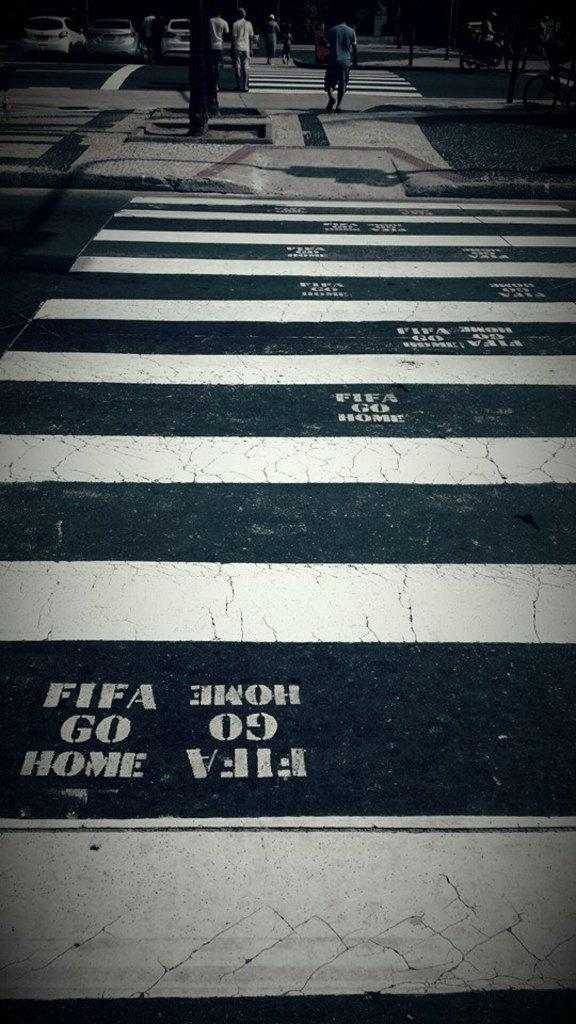What are the people in the image doing? The people in the image are walking. Where are the people walking in the image? The people are walking on a zebra crossing. What else can be seen in the image besides the people walking? There are cars in the image. Where are the cars located in the image? The cars are in the left top corner of the image. What type of breakfast is being served in the image? There is no breakfast present in the image; it features people walking on a zebra crossing and cars in the left top corner. 